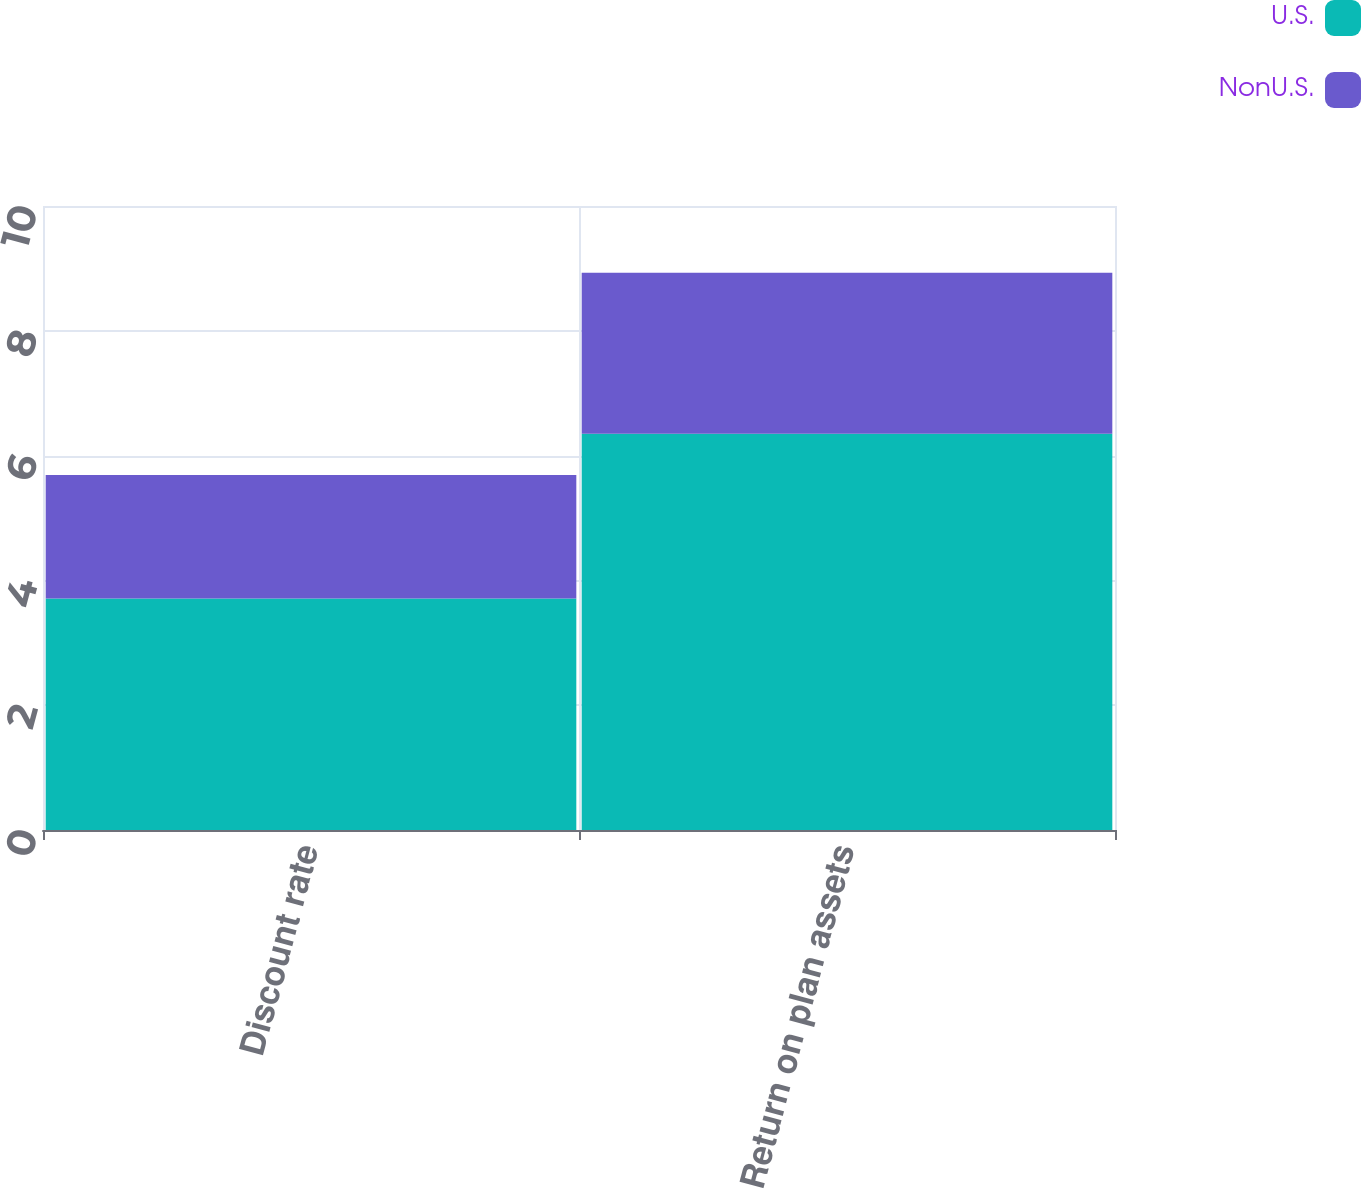<chart> <loc_0><loc_0><loc_500><loc_500><stacked_bar_chart><ecel><fcel>Discount rate<fcel>Return on plan assets<nl><fcel>U.S.<fcel>3.71<fcel>6.35<nl><fcel>NonU.S.<fcel>1.98<fcel>2.58<nl></chart> 